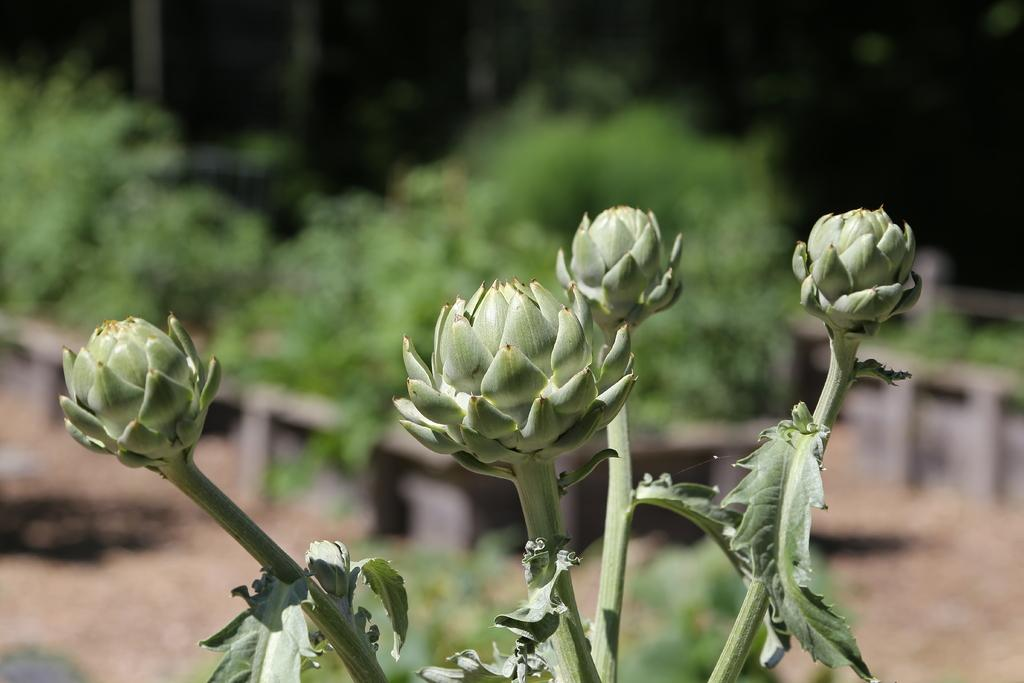What type of plant is visible in the picture? There is a plant with buds in the picture. Can you describe the background of the image? The background of the image is blurred. What type of engine is visible in the picture? There is no engine present in the picture; it features a plant with buds and a blurred background. 